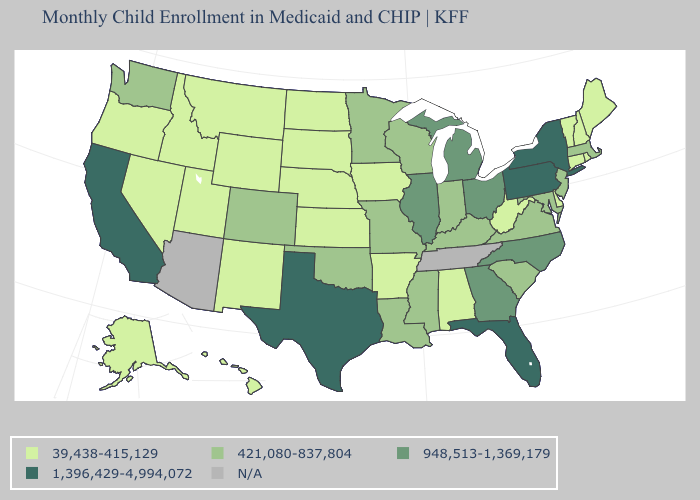Does California have the highest value in the West?
Give a very brief answer. Yes. Does Indiana have the lowest value in the USA?
Answer briefly. No. Among the states that border Massachusetts , which have the highest value?
Be succinct. New York. Name the states that have a value in the range 948,513-1,369,179?
Answer briefly. Georgia, Illinois, Michigan, North Carolina, Ohio. Name the states that have a value in the range 1,396,429-4,994,072?
Concise answer only. California, Florida, New York, Pennsylvania, Texas. Name the states that have a value in the range N/A?
Keep it brief. Arizona, Tennessee. Name the states that have a value in the range 421,080-837,804?
Answer briefly. Colorado, Indiana, Kentucky, Louisiana, Maryland, Massachusetts, Minnesota, Mississippi, Missouri, New Jersey, Oklahoma, South Carolina, Virginia, Washington, Wisconsin. What is the value of Virginia?
Concise answer only. 421,080-837,804. Name the states that have a value in the range 39,438-415,129?
Answer briefly. Alabama, Alaska, Arkansas, Connecticut, Delaware, Hawaii, Idaho, Iowa, Kansas, Maine, Montana, Nebraska, Nevada, New Hampshire, New Mexico, North Dakota, Oregon, Rhode Island, South Dakota, Utah, Vermont, West Virginia, Wyoming. What is the highest value in the South ?
Be succinct. 1,396,429-4,994,072. What is the value of Texas?
Quick response, please. 1,396,429-4,994,072. Is the legend a continuous bar?
Be succinct. No. Name the states that have a value in the range 948,513-1,369,179?
Write a very short answer. Georgia, Illinois, Michigan, North Carolina, Ohio. Does the map have missing data?
Short answer required. Yes. 